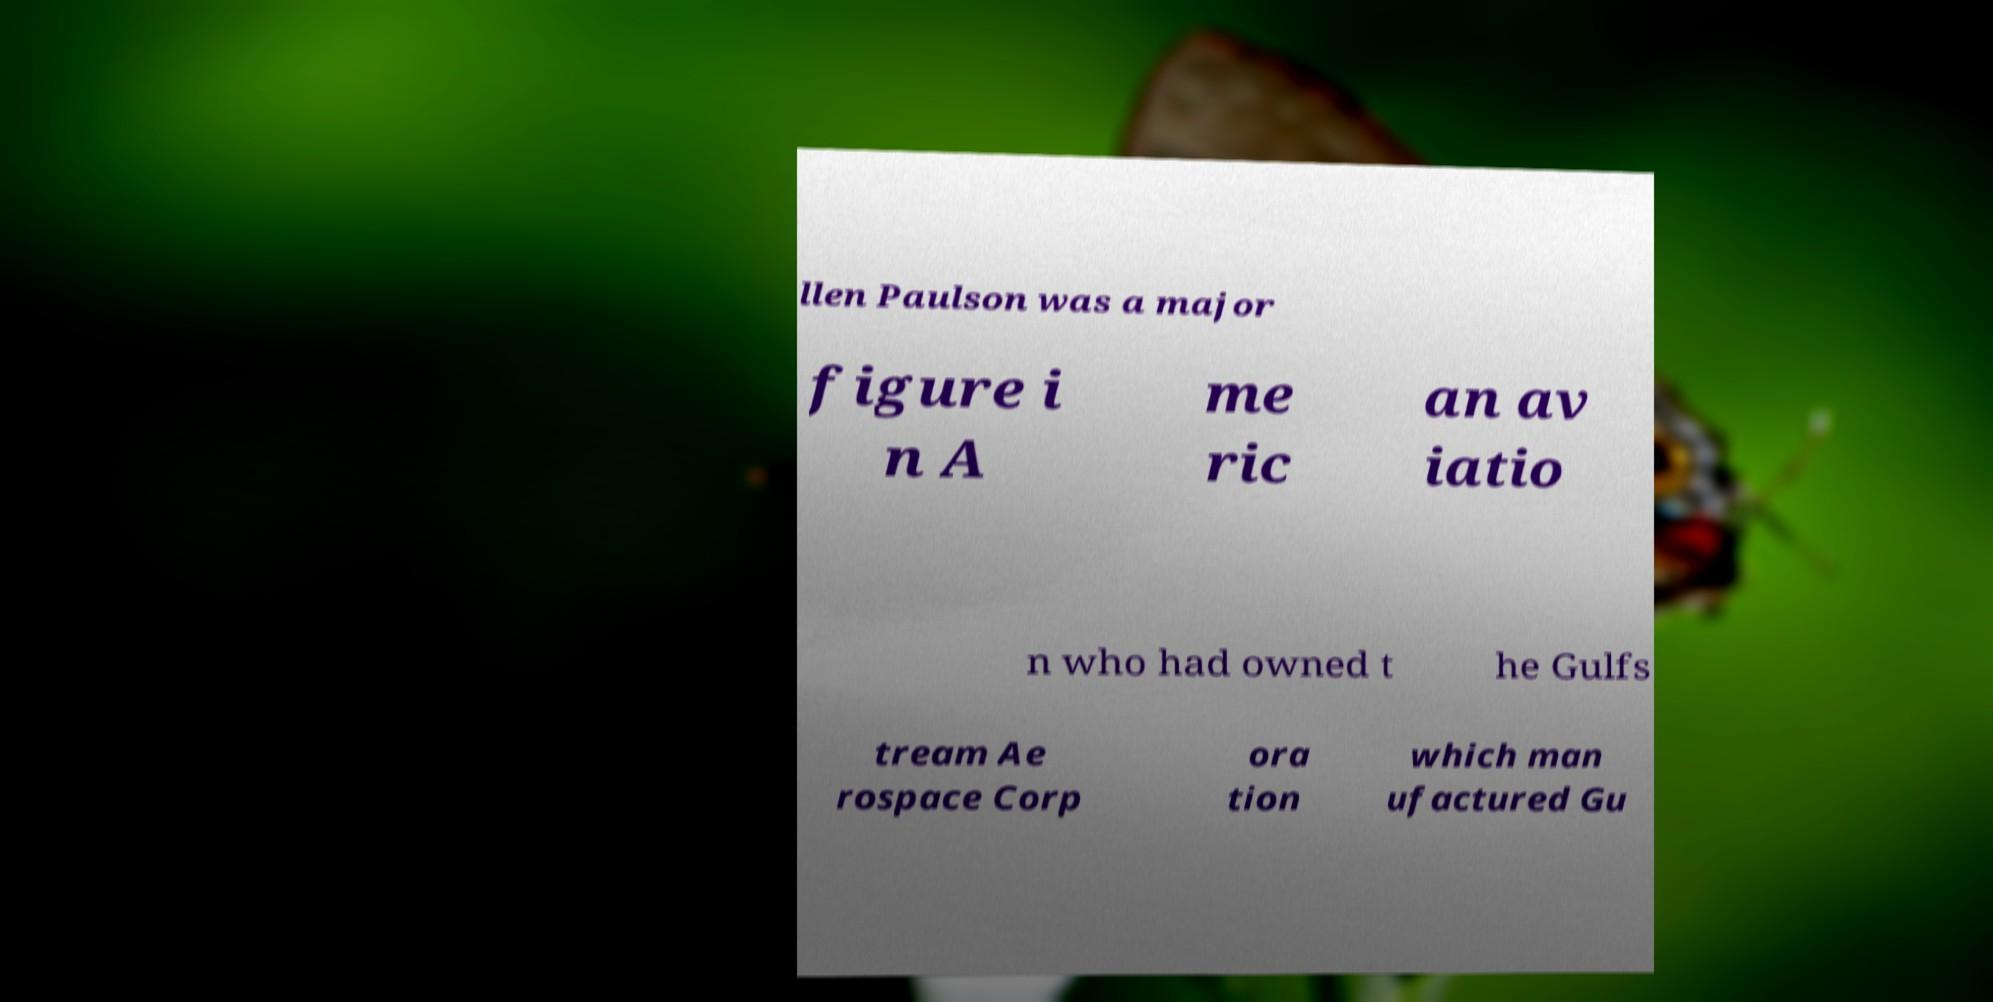What messages or text are displayed in this image? I need them in a readable, typed format. llen Paulson was a major figure i n A me ric an av iatio n who had owned t he Gulfs tream Ae rospace Corp ora tion which man ufactured Gu 